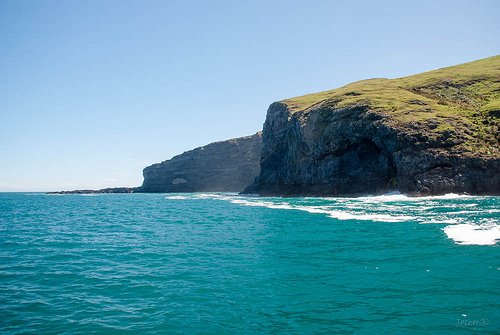<image>
Can you confirm if the rock is above the water? Yes. The rock is positioned above the water in the vertical space, higher up in the scene. 